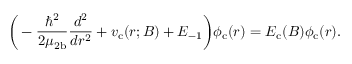<formula> <loc_0><loc_0><loc_500><loc_500>\left ( - \frac { \hbar { ^ } { 2 } } { 2 \mu _ { 2 b } } \frac { d ^ { 2 } } { d r ^ { 2 } } + v _ { c } ( r ; B ) + E _ { - 1 } \right ) \phi _ { c } ( r ) = E _ { c } ( B ) \phi _ { c } ( r ) .</formula> 